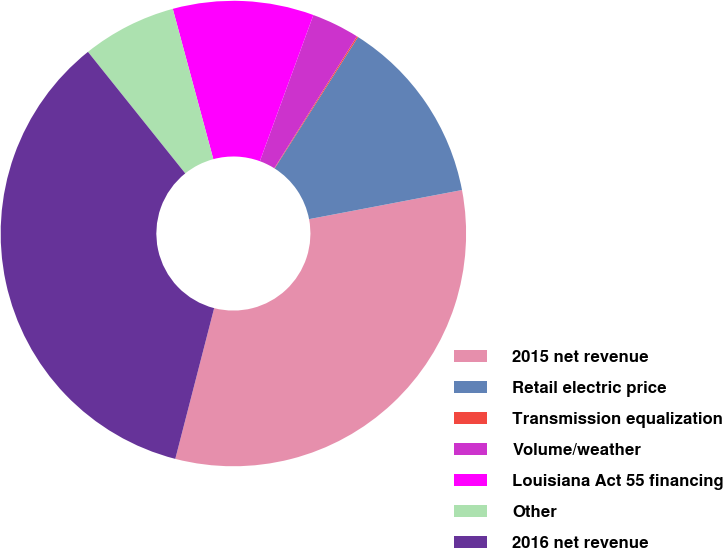Convert chart to OTSL. <chart><loc_0><loc_0><loc_500><loc_500><pie_chart><fcel>2015 net revenue<fcel>Retail electric price<fcel>Transmission equalization<fcel>Volume/weather<fcel>Louisiana Act 55 financing<fcel>Other<fcel>2016 net revenue<nl><fcel>32.01%<fcel>13.01%<fcel>0.09%<fcel>3.32%<fcel>9.78%<fcel>6.55%<fcel>35.24%<nl></chart> 